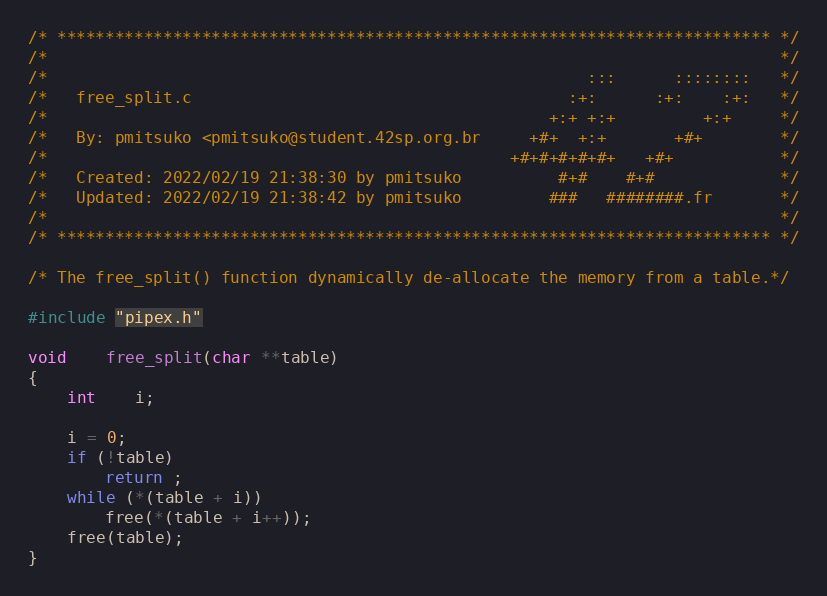Convert code to text. <code><loc_0><loc_0><loc_500><loc_500><_C_>/* ************************************************************************** */
/*                                                                            */
/*                                                        :::      ::::::::   */
/*   free_split.c                                       :+:      :+:    :+:   */
/*                                                    +:+ +:+         +:+     */
/*   By: pmitsuko <pmitsuko@student.42sp.org.br     +#+  +:+       +#+        */
/*                                                +#+#+#+#+#+   +#+           */
/*   Created: 2022/02/19 21:38:30 by pmitsuko          #+#    #+#             */
/*   Updated: 2022/02/19 21:38:42 by pmitsuko         ###   ########.fr       */
/*                                                                            */
/* ************************************************************************** */

/* The free_split() function dynamically de-allocate the memory from a table.*/

#include "pipex.h"

void	free_split(char **table)
{
	int	i;

	i = 0;
	if (!table)
		return ;
	while (*(table + i))
		free(*(table + i++));
	free(table);
}
</code> 